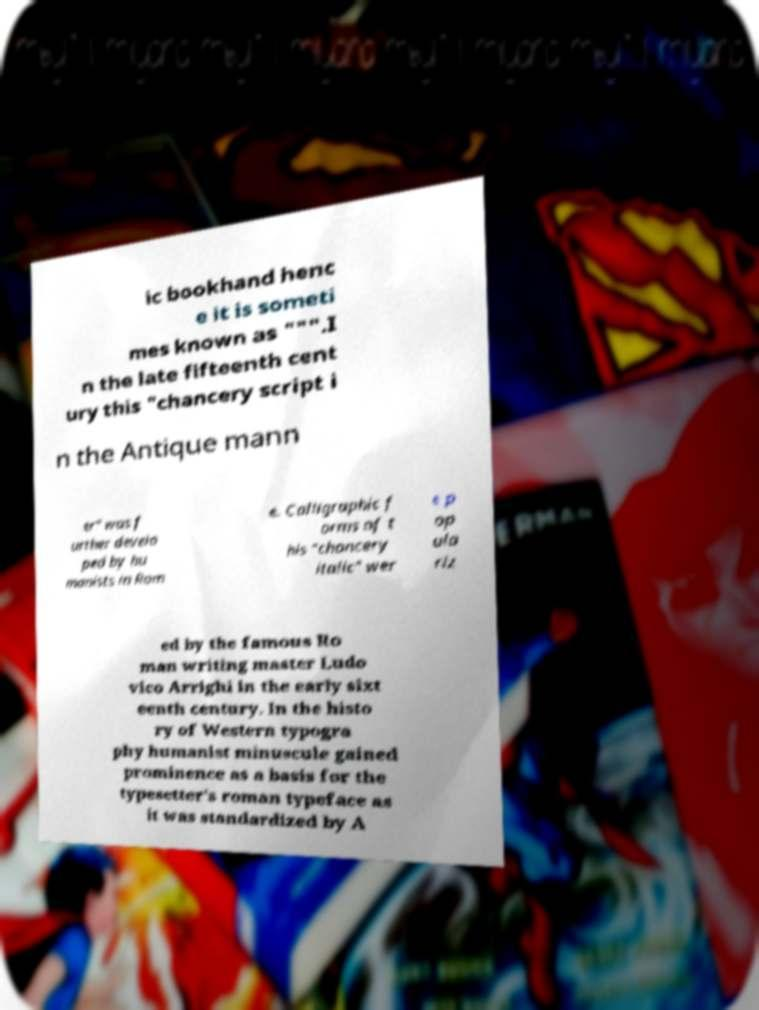I need the written content from this picture converted into text. Can you do that? ic bookhand henc e it is someti mes known as """.I n the late fifteenth cent ury this "chancery script i n the Antique mann er" was f urther develo ped by hu manists in Rom e. Calligraphic f orms of t his "chancery italic" wer e p op ula riz ed by the famous Ro man writing master Ludo vico Arrighi in the early sixt eenth century. In the histo ry of Western typogra phy humanist minuscule gained prominence as a basis for the typesetter's roman typeface as it was standardized by A 